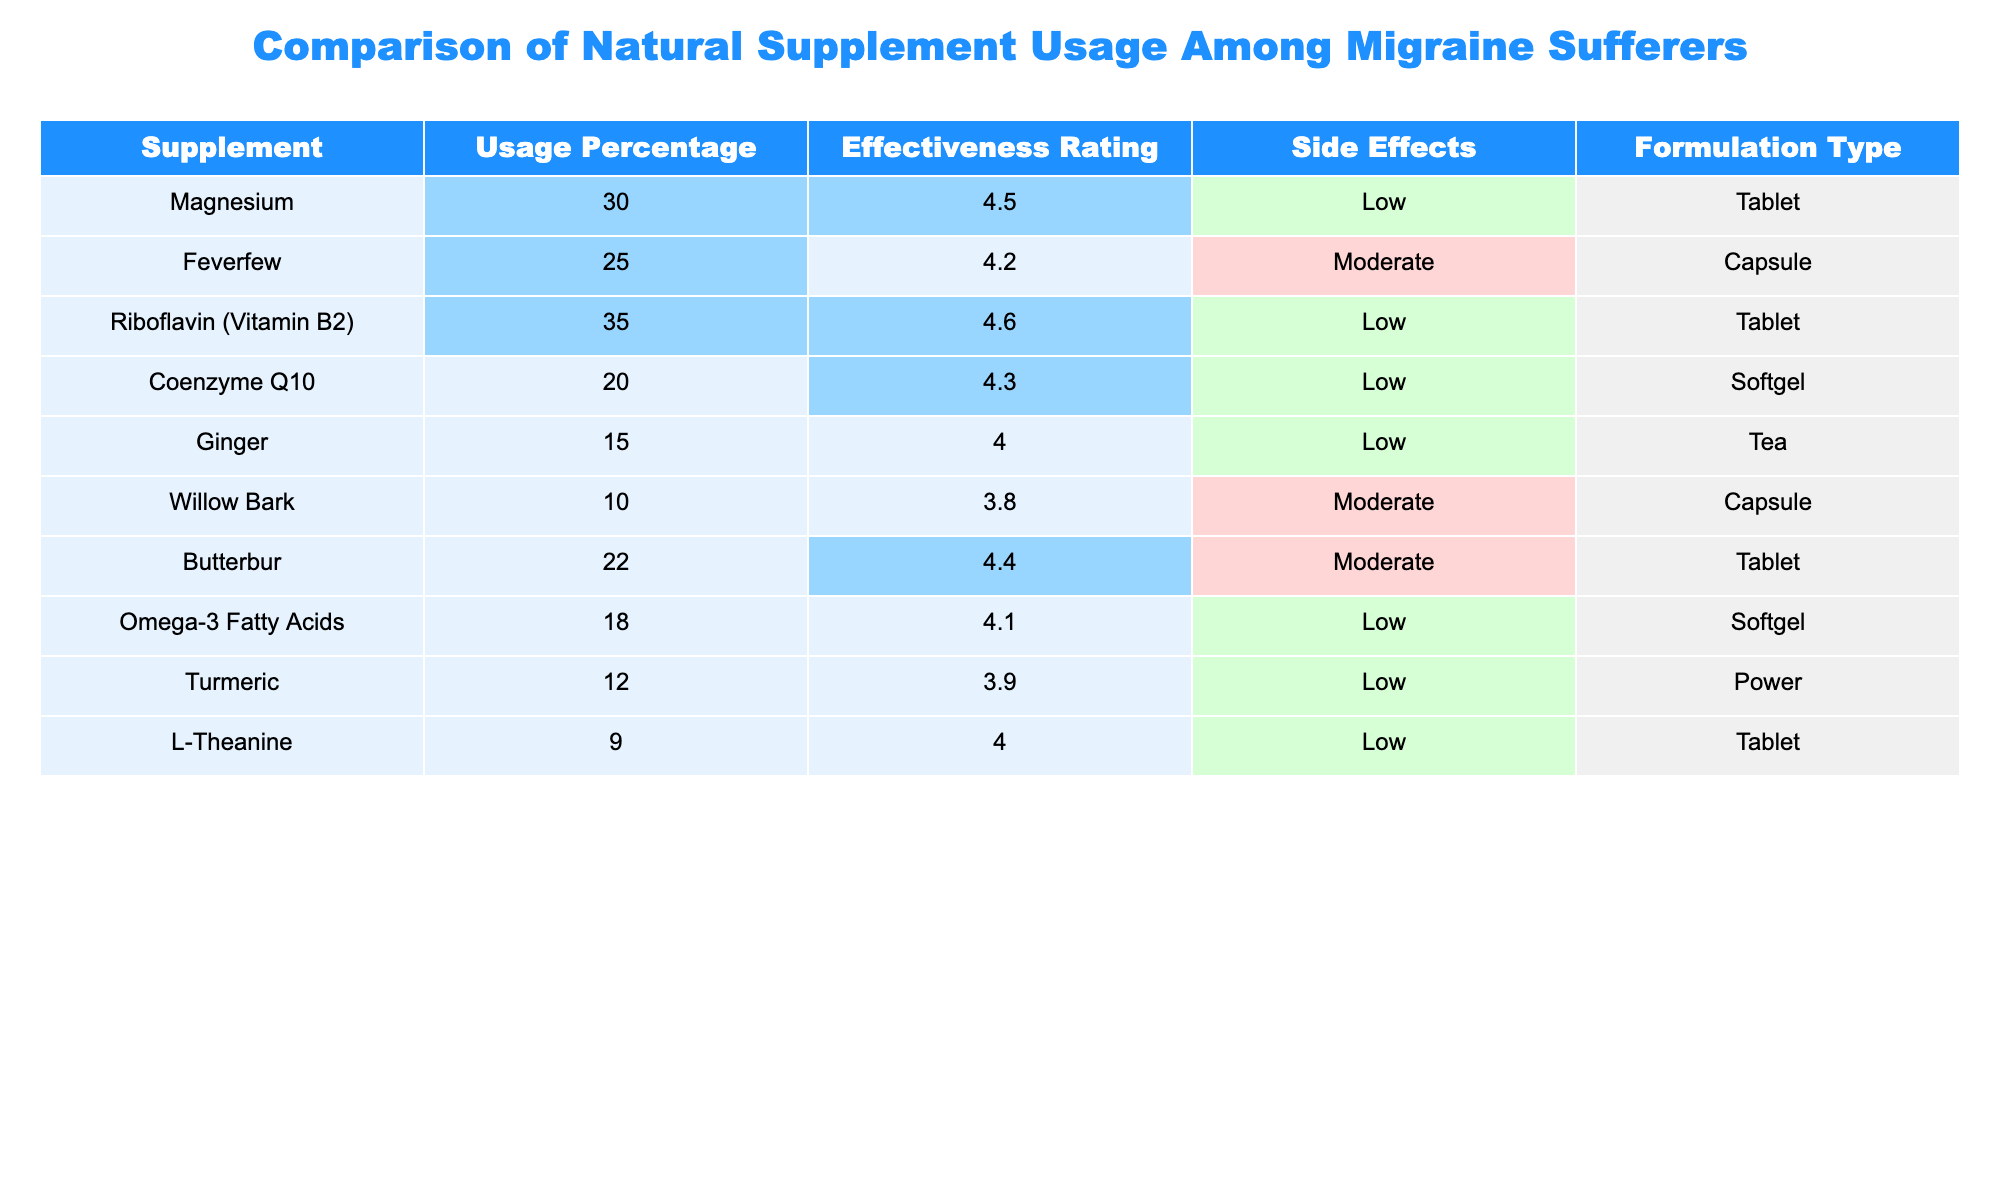What is the usage percentage of Riboflavin (Vitamin B2)? The table shows that Riboflavin (Vitamin B2) has a usage percentage of 35%.
Answer: 35% Which supplement has the highest effectiveness rating? According to the table, Riboflavin (Vitamin B2) has the highest effectiveness rating at 4.6.
Answer: 4.6 How many supplements have a moderate side effect rating? From the table, Feverfew, Willow Bark, and Butterbur are noted for having moderate side effects. This totals to three supplements.
Answer: 3 What is the average usage percentage of supplements with low side effects? First, identify the supplements with low side effects: Magnesium, Riboflavin (Vitamin B2), Coenzyme Q10, Ginger, Omega-3 fatty acids, and L-Theanine. Their usage percentages are 30, 35, 20, 15, 18, and 9. Next, sum these values (30 + 35 + 20 + 15 + 18 + 9 = 127). Then divide by the number of supplements (127 / 6 ≈ 21.17), resulting in an average usage percentage of approximately 21.17.
Answer: Approximately 21.17% Is the effectiveness rating of Ginger higher than that of Turmeric? The effectiveness rating for Ginger is 4.0 while Turmeric's is 3.9. Since 4.0 is greater than 3.9, the statement is true.
Answer: Yes Which two supplements have the same formulation type? The table indicates that both Feverfew and Willow Bark are encapsulated in capsules. Therefore, these two share the same formulation type.
Answer: Feverfew and Willow Bark What is the difference in usage percentage between the most used and least used supplements? The most used supplement is Riboflavin (Vitamin B2) at 35%, and the least used supplement is Willow Bark at 10%. The difference is 35 - 10 = 25%.
Answer: 25% If we add the effectiveness ratings of all supplements, what would the result be? The effectiveness ratings are 4.5 (Magnesium), 4.2 (Feverfew), 4.6 (Riboflavin), 4.3 (Coenzyme Q10), 4.0 (Ginger), 3.8 (Willow Bark), 4.4 (Butterbur), 4.1 (Omega-3), 3.9 (Turmeric), and 4.0 (L-Theanine). Summing these gives 4.5 + 4.2 + 4.6 + 4.3 + 4.0 + 3.8 + 4.4 + 4.1 + 3.9 + 4.0 = 43.8.
Answer: 43.8 